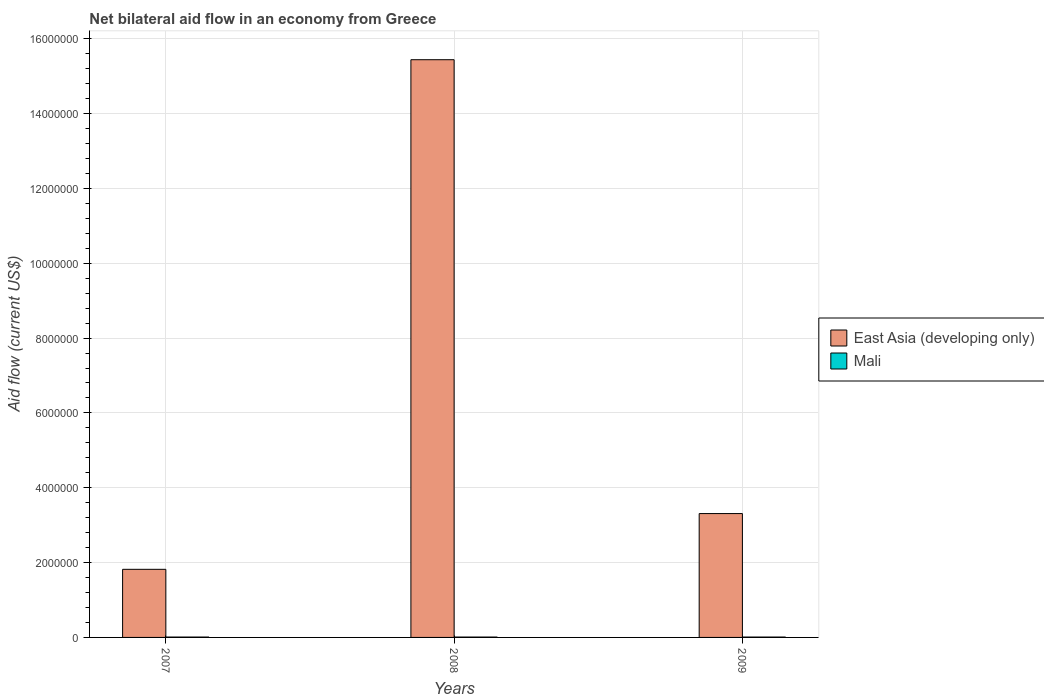Are the number of bars per tick equal to the number of legend labels?
Offer a very short reply. Yes. Are the number of bars on each tick of the X-axis equal?
Provide a succinct answer. Yes. In how many cases, is the number of bars for a given year not equal to the number of legend labels?
Offer a very short reply. 0. What is the net bilateral aid flow in East Asia (developing only) in 2008?
Ensure brevity in your answer.  1.54e+07. Across all years, what is the minimum net bilateral aid flow in East Asia (developing only)?
Give a very brief answer. 1.82e+06. In which year was the net bilateral aid flow in Mali minimum?
Give a very brief answer. 2007. What is the total net bilateral aid flow in East Asia (developing only) in the graph?
Make the answer very short. 2.06e+07. What is the difference between the net bilateral aid flow in East Asia (developing only) in 2008 and that in 2009?
Ensure brevity in your answer.  1.21e+07. What is the difference between the net bilateral aid flow in East Asia (developing only) in 2007 and the net bilateral aid flow in Mali in 2009?
Keep it short and to the point. 1.81e+06. In the year 2008, what is the difference between the net bilateral aid flow in Mali and net bilateral aid flow in East Asia (developing only)?
Keep it short and to the point. -1.54e+07. What is the ratio of the net bilateral aid flow in Mali in 2007 to that in 2008?
Your answer should be very brief. 1. Is the net bilateral aid flow in East Asia (developing only) in 2007 less than that in 2009?
Give a very brief answer. Yes. Is the difference between the net bilateral aid flow in Mali in 2007 and 2008 greater than the difference between the net bilateral aid flow in East Asia (developing only) in 2007 and 2008?
Offer a terse response. Yes. What is the difference between the highest and the second highest net bilateral aid flow in Mali?
Your response must be concise. 0. What is the difference between the highest and the lowest net bilateral aid flow in East Asia (developing only)?
Give a very brief answer. 1.36e+07. In how many years, is the net bilateral aid flow in Mali greater than the average net bilateral aid flow in Mali taken over all years?
Provide a short and direct response. 0. What does the 2nd bar from the left in 2007 represents?
Provide a short and direct response. Mali. What does the 2nd bar from the right in 2007 represents?
Make the answer very short. East Asia (developing only). How many bars are there?
Offer a terse response. 6. How many years are there in the graph?
Offer a terse response. 3. What is the difference between two consecutive major ticks on the Y-axis?
Provide a succinct answer. 2.00e+06. Where does the legend appear in the graph?
Your answer should be compact. Center right. How many legend labels are there?
Your answer should be very brief. 2. How are the legend labels stacked?
Offer a terse response. Vertical. What is the title of the graph?
Make the answer very short. Net bilateral aid flow in an economy from Greece. What is the label or title of the X-axis?
Keep it short and to the point. Years. What is the label or title of the Y-axis?
Your answer should be compact. Aid flow (current US$). What is the Aid flow (current US$) in East Asia (developing only) in 2007?
Your answer should be very brief. 1.82e+06. What is the Aid flow (current US$) in Mali in 2007?
Ensure brevity in your answer.  10000. What is the Aid flow (current US$) of East Asia (developing only) in 2008?
Offer a terse response. 1.54e+07. What is the Aid flow (current US$) of East Asia (developing only) in 2009?
Offer a terse response. 3.31e+06. Across all years, what is the maximum Aid flow (current US$) of East Asia (developing only)?
Your answer should be compact. 1.54e+07. Across all years, what is the maximum Aid flow (current US$) in Mali?
Offer a terse response. 10000. Across all years, what is the minimum Aid flow (current US$) in East Asia (developing only)?
Make the answer very short. 1.82e+06. What is the total Aid flow (current US$) of East Asia (developing only) in the graph?
Make the answer very short. 2.06e+07. What is the difference between the Aid flow (current US$) of East Asia (developing only) in 2007 and that in 2008?
Offer a terse response. -1.36e+07. What is the difference between the Aid flow (current US$) of Mali in 2007 and that in 2008?
Keep it short and to the point. 0. What is the difference between the Aid flow (current US$) of East Asia (developing only) in 2007 and that in 2009?
Offer a very short reply. -1.49e+06. What is the difference between the Aid flow (current US$) of East Asia (developing only) in 2008 and that in 2009?
Make the answer very short. 1.21e+07. What is the difference between the Aid flow (current US$) of East Asia (developing only) in 2007 and the Aid flow (current US$) of Mali in 2008?
Provide a succinct answer. 1.81e+06. What is the difference between the Aid flow (current US$) in East Asia (developing only) in 2007 and the Aid flow (current US$) in Mali in 2009?
Your answer should be compact. 1.81e+06. What is the difference between the Aid flow (current US$) of East Asia (developing only) in 2008 and the Aid flow (current US$) of Mali in 2009?
Ensure brevity in your answer.  1.54e+07. What is the average Aid flow (current US$) of East Asia (developing only) per year?
Give a very brief answer. 6.86e+06. In the year 2007, what is the difference between the Aid flow (current US$) of East Asia (developing only) and Aid flow (current US$) of Mali?
Ensure brevity in your answer.  1.81e+06. In the year 2008, what is the difference between the Aid flow (current US$) of East Asia (developing only) and Aid flow (current US$) of Mali?
Provide a succinct answer. 1.54e+07. In the year 2009, what is the difference between the Aid flow (current US$) of East Asia (developing only) and Aid flow (current US$) of Mali?
Keep it short and to the point. 3.30e+06. What is the ratio of the Aid flow (current US$) in East Asia (developing only) in 2007 to that in 2008?
Your answer should be very brief. 0.12. What is the ratio of the Aid flow (current US$) in East Asia (developing only) in 2007 to that in 2009?
Your response must be concise. 0.55. What is the ratio of the Aid flow (current US$) in East Asia (developing only) in 2008 to that in 2009?
Offer a very short reply. 4.66. What is the ratio of the Aid flow (current US$) of Mali in 2008 to that in 2009?
Give a very brief answer. 1. What is the difference between the highest and the second highest Aid flow (current US$) of East Asia (developing only)?
Your answer should be compact. 1.21e+07. What is the difference between the highest and the second highest Aid flow (current US$) of Mali?
Make the answer very short. 0. What is the difference between the highest and the lowest Aid flow (current US$) in East Asia (developing only)?
Ensure brevity in your answer.  1.36e+07. 